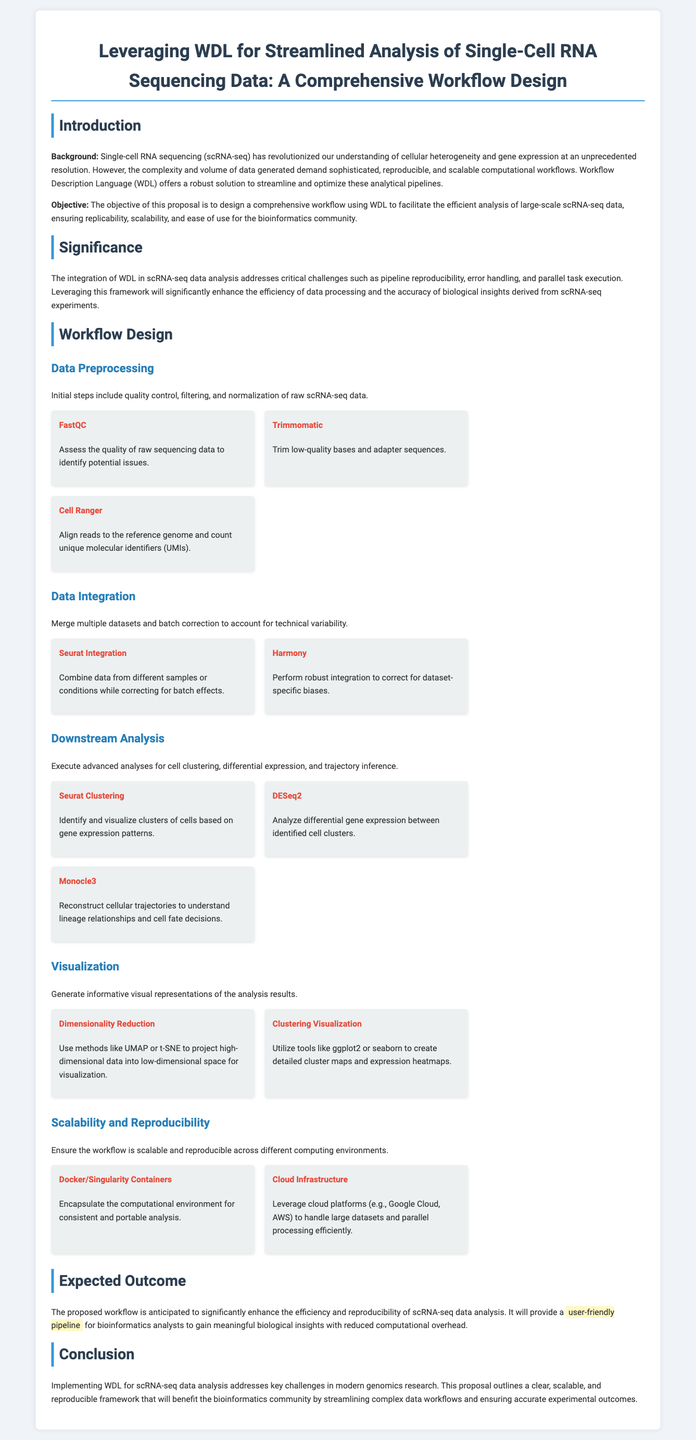What is the objective of the proposal? The objective is to design a comprehensive workflow using WDL to facilitate the efficient analysis of large-scale scRNA-seq data.
Answer: facilitate the efficient analysis of large-scale scRNA-seq data What are the initial steps in Data Preprocessing? The initial steps include quality control, filtering, and normalization of raw scRNA-seq data.
Answer: quality control, filtering, and normalization Which tool is used for Quality Assessment? The tool used for quality assessment of raw sequencing data is FastQC.
Answer: FastQC What technology is proposed to ensure scalability? The proposed technology to ensure scalability is Cloud Infrastructure.
Answer: Cloud Infrastructure What is the expected outcome of the proposed workflow? The expected outcome is to significantly enhance the efficiency and reproducibility of scRNA-seq data analysis.
Answer: enhance the efficiency and reproducibility of scRNA-seq data analysis What methods are suggested for Dimensionality Reduction? Methods suggested for dimensionality reduction include UMAP or t-SNE.
Answer: UMAP or t-SNE What does the workflow design aim to address? The workflow design aims to address pipeline reproducibility, error handling, and parallel task execution.
Answer: pipeline reproducibility, error handling, and parallel task execution Which container technologies are mentioned in the proposal? The container technologies mentioned in the proposal are Docker and Singularity.
Answer: Docker and Singularity What type of analysis does Monocle3 perform? Monocle3 performs the analysis of cellular trajectories to understand lineage relationships.
Answer: cellular trajectories to understand lineage relationships 